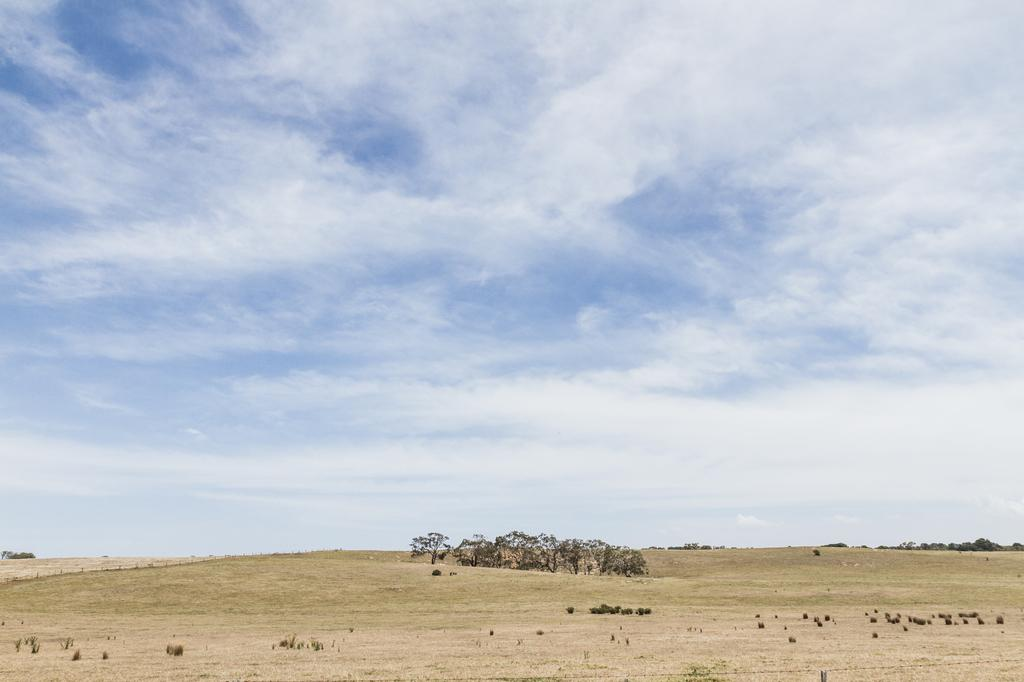What type of vegetation can be seen in the image? There are plants and trees in the image. What is covering the ground in the image? There is grass on the surface at the bottom of the image. What can be seen in the sky at the top of the image? There are clouds in the sky at the top of the image. What type of potato is being used as a friction device in the image? There is no potato present in the image, and no friction device is mentioned or visible. 